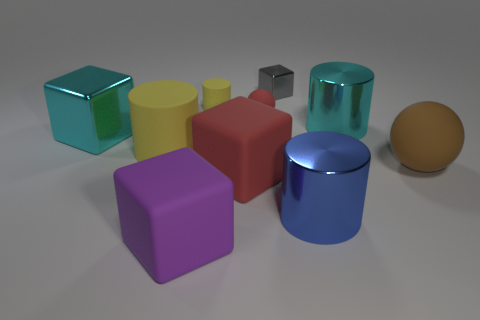What is the size of the object that is the same color as the tiny sphere?
Provide a short and direct response. Large. What is the size of the red object that is in front of the brown matte sphere?
Your answer should be very brief. Large. Is the number of blue metal cylinders that are on the left side of the big cyan block less than the number of large purple matte cubes that are to the right of the purple rubber object?
Offer a very short reply. No. What color is the large metallic block?
Provide a short and direct response. Cyan. Are there any big cylinders that have the same color as the tiny rubber cylinder?
Offer a terse response. Yes. There is a large rubber thing in front of the big metallic cylinder in front of the large metallic object to the right of the large blue object; what is its shape?
Give a very brief answer. Cube. What is the material of the sphere that is right of the tiny gray metallic cube?
Your answer should be compact. Rubber. What size is the rubber ball behind the matte sphere in front of the large cyan thing on the left side of the tiny block?
Your answer should be compact. Small. Do the purple cube and the metallic thing left of the tiny cube have the same size?
Provide a succinct answer. Yes. The metallic cylinder behind the big brown sphere is what color?
Your answer should be very brief. Cyan. 